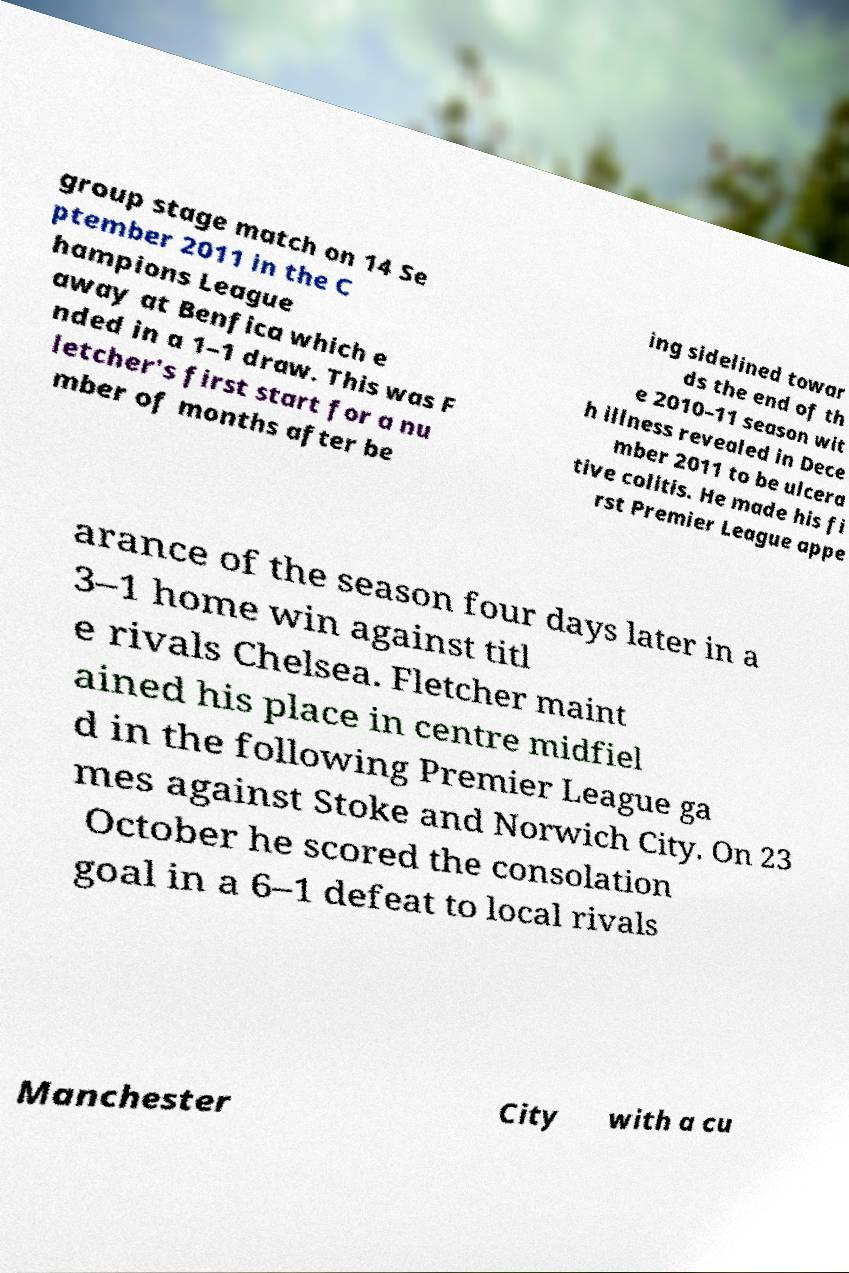What messages or text are displayed in this image? I need them in a readable, typed format. group stage match on 14 Se ptember 2011 in the C hampions League away at Benfica which e nded in a 1–1 draw. This was F letcher's first start for a nu mber of months after be ing sidelined towar ds the end of th e 2010–11 season wit h illness revealed in Dece mber 2011 to be ulcera tive colitis. He made his fi rst Premier League appe arance of the season four days later in a 3–1 home win against titl e rivals Chelsea. Fletcher maint ained his place in centre midfiel d in the following Premier League ga mes against Stoke and Norwich City. On 23 October he scored the consolation goal in a 6–1 defeat to local rivals Manchester City with a cu 